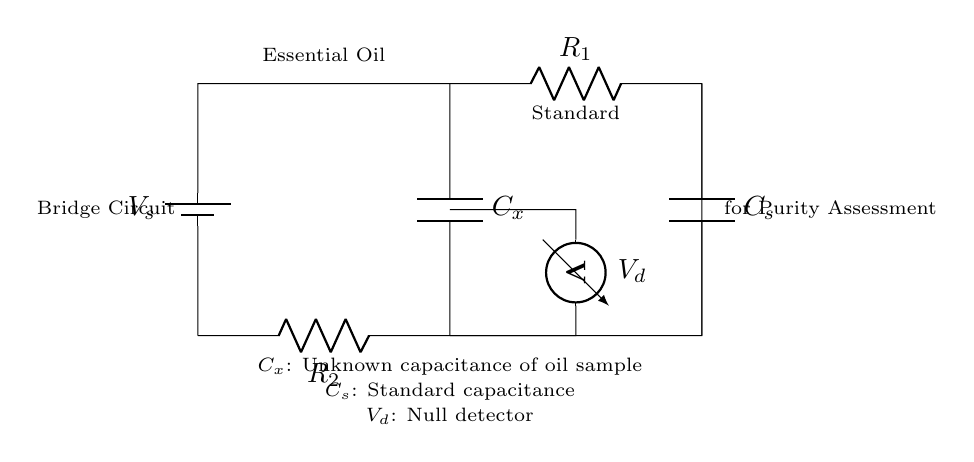What is the purpose of the bridge circuit? The bridge circuit is specifically designed to assess the purity of essential oils by comparing the unknown capacitance of the oil sample to a standard capacitance.
Answer: Purity assessment What does the voltmeter measure in this circuit? The voltmeter measures the potential difference, or voltage, across the bridge circuit, which helps determine the balance between the capacitances.
Answer: Voltage What are the two capacitances present in the circuit? The circuit includes an unknown capacitance denoted as Cx and a standard capacitance denoted as Cs, used for comparison.
Answer: Cx and Cs How many resistors are in the circuit? There are two resistors, R1 and R2, that form part of the bridge circuit and help maintain the balance required for accurate capacitance measurement.
Answer: Two What happens if Cx equals Cs? If Cx equals Cs, the circuit reaches a null condition, meaning the voltmeter reads zero, indicating that the oil sample has the same capacitance as the standard.
Answer: Null condition What is the role of the battery in this circuit? The battery supplies the necessary voltage to the circuit to enable measurement of the voltage drop across the bridge, thereby facilitating the comparison of capacitances.
Answer: Supply voltage What is represented by Vd in the circuit? Vd represents the output voltage reading on the voltmeter, which is used to indicate the balance status of the bridge circuit.
Answer: Output voltage 